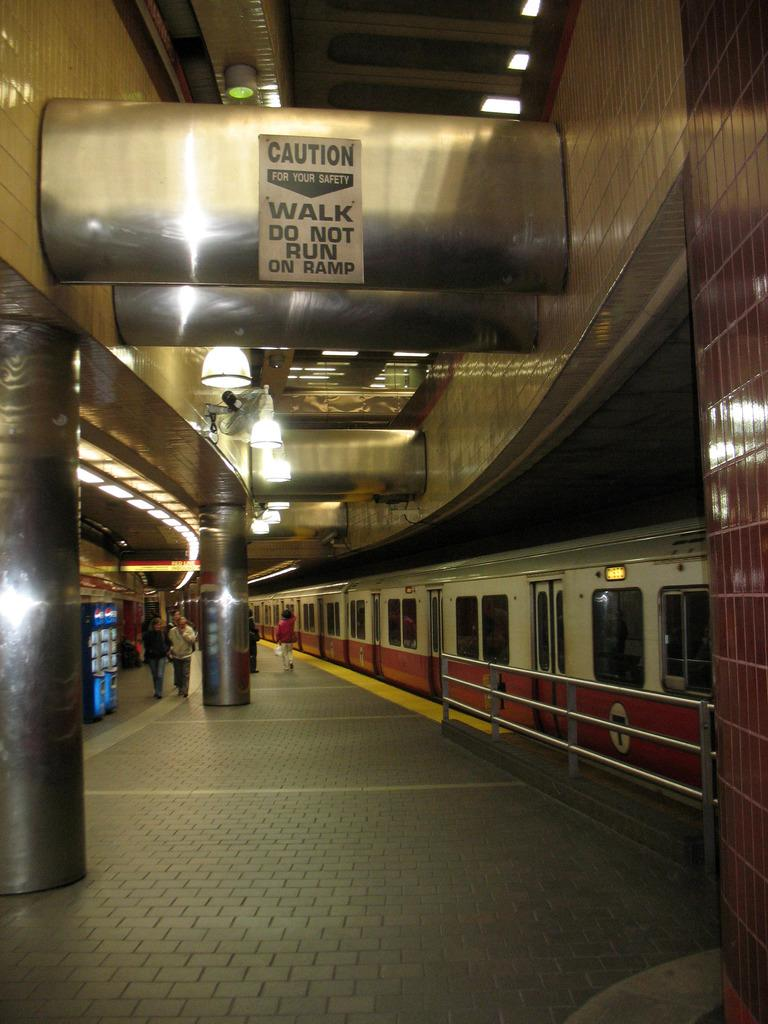What type of location is depicted in the image? The image is an inside view of a railway station. What can be seen inside the railway station? There is a train and a platform in the image. What are the people in the image doing? People are walking on the platform. Is there any information provided in the image? Yes, there is a notice written at the top of the image. What type of sheet is covering the train in the image? There is no sheet covering the train in the image; the train is visible. What type of dinner is being served on the platform in the image? There is no dinner being served in the image; people are simply walking on the platform. 